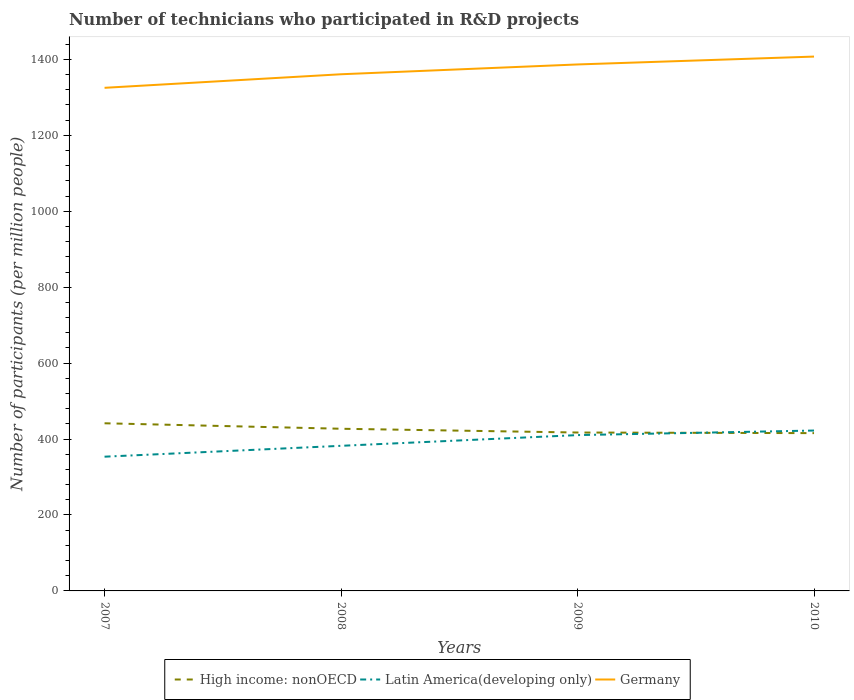Is the number of lines equal to the number of legend labels?
Provide a succinct answer. Yes. Across all years, what is the maximum number of technicians who participated in R&D projects in Germany?
Give a very brief answer. 1325.22. What is the total number of technicians who participated in R&D projects in High income: nonOECD in the graph?
Ensure brevity in your answer.  1.61. What is the difference between the highest and the second highest number of technicians who participated in R&D projects in High income: nonOECD?
Offer a very short reply. 25.96. What is the difference between the highest and the lowest number of technicians who participated in R&D projects in Latin America(developing only)?
Provide a succinct answer. 2. What is the difference between two consecutive major ticks on the Y-axis?
Offer a very short reply. 200. Are the values on the major ticks of Y-axis written in scientific E-notation?
Provide a succinct answer. No. Does the graph contain any zero values?
Make the answer very short. No. Does the graph contain grids?
Your response must be concise. No. What is the title of the graph?
Keep it short and to the point. Number of technicians who participated in R&D projects. Does "High income: nonOECD" appear as one of the legend labels in the graph?
Provide a succinct answer. Yes. What is the label or title of the X-axis?
Offer a very short reply. Years. What is the label or title of the Y-axis?
Make the answer very short. Number of participants (per million people). What is the Number of participants (per million people) in High income: nonOECD in 2007?
Your response must be concise. 441.59. What is the Number of participants (per million people) in Latin America(developing only) in 2007?
Provide a succinct answer. 353.59. What is the Number of participants (per million people) of Germany in 2007?
Your response must be concise. 1325.22. What is the Number of participants (per million people) of High income: nonOECD in 2008?
Your answer should be very brief. 427.17. What is the Number of participants (per million people) in Latin America(developing only) in 2008?
Provide a succinct answer. 382.22. What is the Number of participants (per million people) in Germany in 2008?
Your answer should be compact. 1360.92. What is the Number of participants (per million people) in High income: nonOECD in 2009?
Provide a succinct answer. 417.23. What is the Number of participants (per million people) in Latin America(developing only) in 2009?
Your answer should be compact. 410.44. What is the Number of participants (per million people) in Germany in 2009?
Provide a short and direct response. 1386.74. What is the Number of participants (per million people) in High income: nonOECD in 2010?
Keep it short and to the point. 415.62. What is the Number of participants (per million people) of Latin America(developing only) in 2010?
Make the answer very short. 422.45. What is the Number of participants (per million people) of Germany in 2010?
Ensure brevity in your answer.  1407.48. Across all years, what is the maximum Number of participants (per million people) of High income: nonOECD?
Keep it short and to the point. 441.59. Across all years, what is the maximum Number of participants (per million people) of Latin America(developing only)?
Your response must be concise. 422.45. Across all years, what is the maximum Number of participants (per million people) in Germany?
Offer a very short reply. 1407.48. Across all years, what is the minimum Number of participants (per million people) in High income: nonOECD?
Provide a succinct answer. 415.62. Across all years, what is the minimum Number of participants (per million people) of Latin America(developing only)?
Give a very brief answer. 353.59. Across all years, what is the minimum Number of participants (per million people) of Germany?
Your answer should be very brief. 1325.22. What is the total Number of participants (per million people) in High income: nonOECD in the graph?
Make the answer very short. 1701.61. What is the total Number of participants (per million people) in Latin America(developing only) in the graph?
Give a very brief answer. 1568.7. What is the total Number of participants (per million people) of Germany in the graph?
Your answer should be compact. 5480.37. What is the difference between the Number of participants (per million people) in High income: nonOECD in 2007 and that in 2008?
Your response must be concise. 14.42. What is the difference between the Number of participants (per million people) of Latin America(developing only) in 2007 and that in 2008?
Make the answer very short. -28.64. What is the difference between the Number of participants (per million people) of Germany in 2007 and that in 2008?
Your response must be concise. -35.7. What is the difference between the Number of participants (per million people) in High income: nonOECD in 2007 and that in 2009?
Your answer should be compact. 24.35. What is the difference between the Number of participants (per million people) in Latin America(developing only) in 2007 and that in 2009?
Make the answer very short. -56.85. What is the difference between the Number of participants (per million people) of Germany in 2007 and that in 2009?
Make the answer very short. -61.52. What is the difference between the Number of participants (per million people) of High income: nonOECD in 2007 and that in 2010?
Provide a short and direct response. 25.96. What is the difference between the Number of participants (per million people) in Latin America(developing only) in 2007 and that in 2010?
Your answer should be compact. -68.86. What is the difference between the Number of participants (per million people) of Germany in 2007 and that in 2010?
Offer a terse response. -82.26. What is the difference between the Number of participants (per million people) in High income: nonOECD in 2008 and that in 2009?
Your response must be concise. 9.93. What is the difference between the Number of participants (per million people) of Latin America(developing only) in 2008 and that in 2009?
Provide a short and direct response. -28.22. What is the difference between the Number of participants (per million people) of Germany in 2008 and that in 2009?
Your answer should be very brief. -25.82. What is the difference between the Number of participants (per million people) in High income: nonOECD in 2008 and that in 2010?
Ensure brevity in your answer.  11.54. What is the difference between the Number of participants (per million people) in Latin America(developing only) in 2008 and that in 2010?
Provide a succinct answer. -40.22. What is the difference between the Number of participants (per million people) of Germany in 2008 and that in 2010?
Offer a terse response. -46.56. What is the difference between the Number of participants (per million people) of High income: nonOECD in 2009 and that in 2010?
Your answer should be compact. 1.61. What is the difference between the Number of participants (per million people) of Latin America(developing only) in 2009 and that in 2010?
Offer a very short reply. -12.01. What is the difference between the Number of participants (per million people) in Germany in 2009 and that in 2010?
Provide a succinct answer. -20.74. What is the difference between the Number of participants (per million people) in High income: nonOECD in 2007 and the Number of participants (per million people) in Latin America(developing only) in 2008?
Your response must be concise. 59.36. What is the difference between the Number of participants (per million people) of High income: nonOECD in 2007 and the Number of participants (per million people) of Germany in 2008?
Give a very brief answer. -919.34. What is the difference between the Number of participants (per million people) of Latin America(developing only) in 2007 and the Number of participants (per million people) of Germany in 2008?
Offer a terse response. -1007.33. What is the difference between the Number of participants (per million people) in High income: nonOECD in 2007 and the Number of participants (per million people) in Latin America(developing only) in 2009?
Make the answer very short. 31.14. What is the difference between the Number of participants (per million people) in High income: nonOECD in 2007 and the Number of participants (per million people) in Germany in 2009?
Your response must be concise. -945.16. What is the difference between the Number of participants (per million people) of Latin America(developing only) in 2007 and the Number of participants (per million people) of Germany in 2009?
Your answer should be compact. -1033.16. What is the difference between the Number of participants (per million people) of High income: nonOECD in 2007 and the Number of participants (per million people) of Latin America(developing only) in 2010?
Your answer should be compact. 19.14. What is the difference between the Number of participants (per million people) in High income: nonOECD in 2007 and the Number of participants (per million people) in Germany in 2010?
Offer a terse response. -965.9. What is the difference between the Number of participants (per million people) in Latin America(developing only) in 2007 and the Number of participants (per million people) in Germany in 2010?
Offer a very short reply. -1053.9. What is the difference between the Number of participants (per million people) in High income: nonOECD in 2008 and the Number of participants (per million people) in Latin America(developing only) in 2009?
Your answer should be very brief. 16.73. What is the difference between the Number of participants (per million people) of High income: nonOECD in 2008 and the Number of participants (per million people) of Germany in 2009?
Your answer should be very brief. -959.58. What is the difference between the Number of participants (per million people) of Latin America(developing only) in 2008 and the Number of participants (per million people) of Germany in 2009?
Your answer should be very brief. -1004.52. What is the difference between the Number of participants (per million people) of High income: nonOECD in 2008 and the Number of participants (per million people) of Latin America(developing only) in 2010?
Your response must be concise. 4.72. What is the difference between the Number of participants (per million people) of High income: nonOECD in 2008 and the Number of participants (per million people) of Germany in 2010?
Give a very brief answer. -980.31. What is the difference between the Number of participants (per million people) of Latin America(developing only) in 2008 and the Number of participants (per million people) of Germany in 2010?
Keep it short and to the point. -1025.26. What is the difference between the Number of participants (per million people) in High income: nonOECD in 2009 and the Number of participants (per million people) in Latin America(developing only) in 2010?
Keep it short and to the point. -5.21. What is the difference between the Number of participants (per million people) of High income: nonOECD in 2009 and the Number of participants (per million people) of Germany in 2010?
Your response must be concise. -990.25. What is the difference between the Number of participants (per million people) of Latin America(developing only) in 2009 and the Number of participants (per million people) of Germany in 2010?
Keep it short and to the point. -997.04. What is the average Number of participants (per million people) in High income: nonOECD per year?
Offer a very short reply. 425.4. What is the average Number of participants (per million people) in Latin America(developing only) per year?
Give a very brief answer. 392.17. What is the average Number of participants (per million people) of Germany per year?
Provide a short and direct response. 1370.09. In the year 2007, what is the difference between the Number of participants (per million people) of High income: nonOECD and Number of participants (per million people) of Latin America(developing only)?
Provide a succinct answer. 88. In the year 2007, what is the difference between the Number of participants (per million people) in High income: nonOECD and Number of participants (per million people) in Germany?
Give a very brief answer. -883.63. In the year 2007, what is the difference between the Number of participants (per million people) of Latin America(developing only) and Number of participants (per million people) of Germany?
Make the answer very short. -971.63. In the year 2008, what is the difference between the Number of participants (per million people) of High income: nonOECD and Number of participants (per million people) of Latin America(developing only)?
Your response must be concise. 44.94. In the year 2008, what is the difference between the Number of participants (per million people) of High income: nonOECD and Number of participants (per million people) of Germany?
Make the answer very short. -933.75. In the year 2008, what is the difference between the Number of participants (per million people) of Latin America(developing only) and Number of participants (per million people) of Germany?
Your response must be concise. -978.7. In the year 2009, what is the difference between the Number of participants (per million people) of High income: nonOECD and Number of participants (per million people) of Latin America(developing only)?
Ensure brevity in your answer.  6.79. In the year 2009, what is the difference between the Number of participants (per million people) of High income: nonOECD and Number of participants (per million people) of Germany?
Provide a succinct answer. -969.51. In the year 2009, what is the difference between the Number of participants (per million people) of Latin America(developing only) and Number of participants (per million people) of Germany?
Make the answer very short. -976.3. In the year 2010, what is the difference between the Number of participants (per million people) of High income: nonOECD and Number of participants (per million people) of Latin America(developing only)?
Your answer should be compact. -6.82. In the year 2010, what is the difference between the Number of participants (per million people) of High income: nonOECD and Number of participants (per million people) of Germany?
Keep it short and to the point. -991.86. In the year 2010, what is the difference between the Number of participants (per million people) in Latin America(developing only) and Number of participants (per million people) in Germany?
Offer a terse response. -985.04. What is the ratio of the Number of participants (per million people) of High income: nonOECD in 2007 to that in 2008?
Ensure brevity in your answer.  1.03. What is the ratio of the Number of participants (per million people) in Latin America(developing only) in 2007 to that in 2008?
Ensure brevity in your answer.  0.93. What is the ratio of the Number of participants (per million people) of Germany in 2007 to that in 2008?
Offer a terse response. 0.97. What is the ratio of the Number of participants (per million people) of High income: nonOECD in 2007 to that in 2009?
Offer a very short reply. 1.06. What is the ratio of the Number of participants (per million people) in Latin America(developing only) in 2007 to that in 2009?
Ensure brevity in your answer.  0.86. What is the ratio of the Number of participants (per million people) of Germany in 2007 to that in 2009?
Make the answer very short. 0.96. What is the ratio of the Number of participants (per million people) in Latin America(developing only) in 2007 to that in 2010?
Your answer should be very brief. 0.84. What is the ratio of the Number of participants (per million people) in Germany in 2007 to that in 2010?
Provide a succinct answer. 0.94. What is the ratio of the Number of participants (per million people) of High income: nonOECD in 2008 to that in 2009?
Your response must be concise. 1.02. What is the ratio of the Number of participants (per million people) of Latin America(developing only) in 2008 to that in 2009?
Keep it short and to the point. 0.93. What is the ratio of the Number of participants (per million people) in Germany in 2008 to that in 2009?
Offer a very short reply. 0.98. What is the ratio of the Number of participants (per million people) of High income: nonOECD in 2008 to that in 2010?
Keep it short and to the point. 1.03. What is the ratio of the Number of participants (per million people) of Latin America(developing only) in 2008 to that in 2010?
Your answer should be compact. 0.9. What is the ratio of the Number of participants (per million people) in Germany in 2008 to that in 2010?
Offer a very short reply. 0.97. What is the ratio of the Number of participants (per million people) in High income: nonOECD in 2009 to that in 2010?
Provide a short and direct response. 1. What is the ratio of the Number of participants (per million people) in Latin America(developing only) in 2009 to that in 2010?
Provide a short and direct response. 0.97. What is the ratio of the Number of participants (per million people) in Germany in 2009 to that in 2010?
Ensure brevity in your answer.  0.99. What is the difference between the highest and the second highest Number of participants (per million people) of High income: nonOECD?
Provide a short and direct response. 14.42. What is the difference between the highest and the second highest Number of participants (per million people) of Latin America(developing only)?
Keep it short and to the point. 12.01. What is the difference between the highest and the second highest Number of participants (per million people) of Germany?
Provide a succinct answer. 20.74. What is the difference between the highest and the lowest Number of participants (per million people) in High income: nonOECD?
Ensure brevity in your answer.  25.96. What is the difference between the highest and the lowest Number of participants (per million people) of Latin America(developing only)?
Keep it short and to the point. 68.86. What is the difference between the highest and the lowest Number of participants (per million people) in Germany?
Offer a terse response. 82.26. 